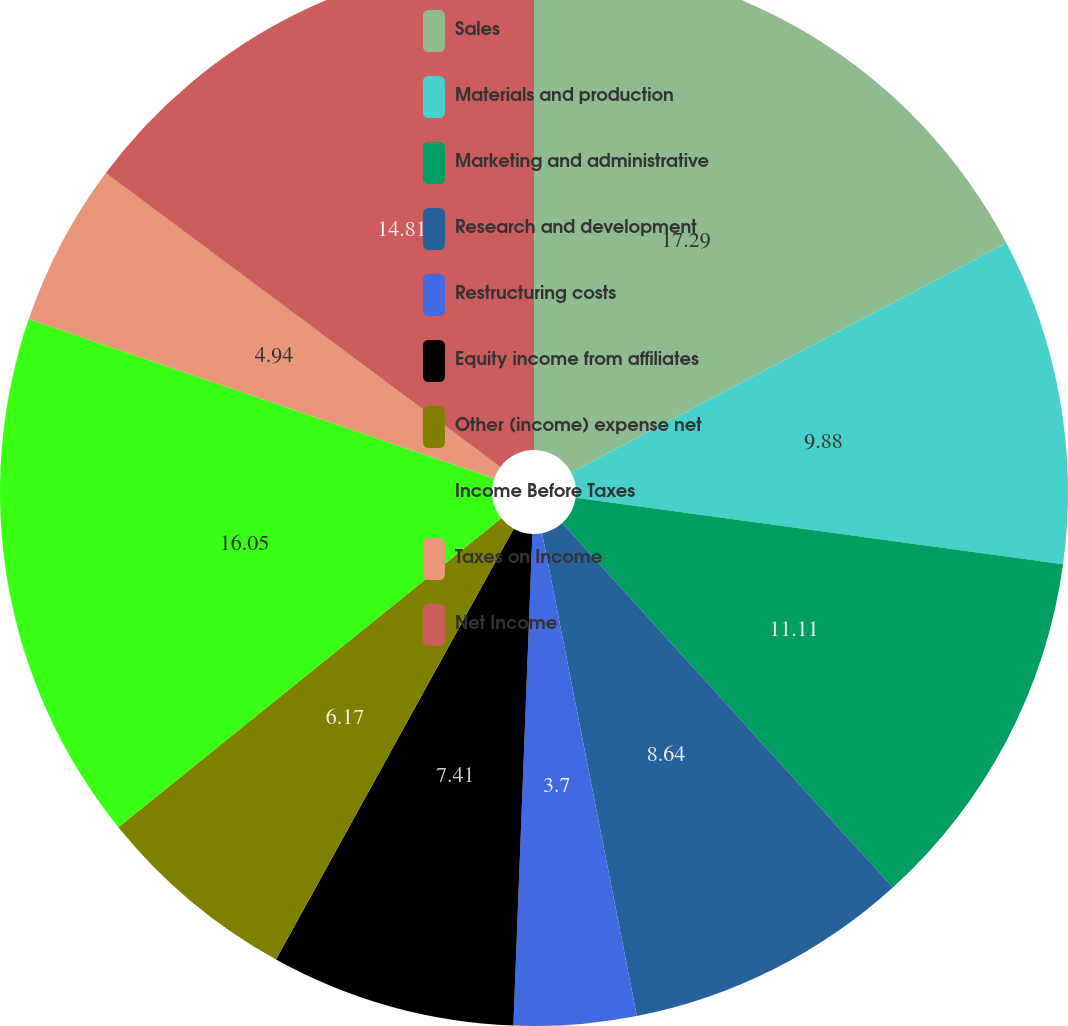<chart> <loc_0><loc_0><loc_500><loc_500><pie_chart><fcel>Sales<fcel>Materials and production<fcel>Marketing and administrative<fcel>Research and development<fcel>Restructuring costs<fcel>Equity income from affiliates<fcel>Other (income) expense net<fcel>Income Before Taxes<fcel>Taxes on Income<fcel>Net Income<nl><fcel>17.28%<fcel>9.88%<fcel>11.11%<fcel>8.64%<fcel>3.7%<fcel>7.41%<fcel>6.17%<fcel>16.05%<fcel>4.94%<fcel>14.81%<nl></chart> 